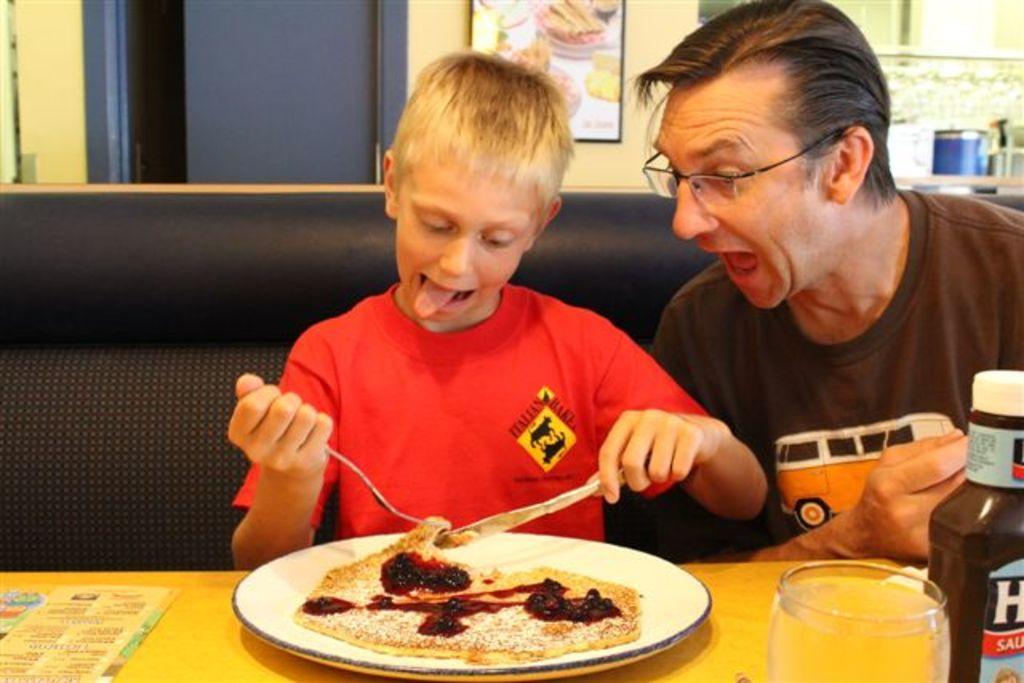Describe this image in one or two sentences. In this image we can see two people. One boy holding a spoon and knife in his hands. At the bottom of the image we can see a card with some text, plate containing food, a glass and a bottle placed on the table. On the right side of the image we can see some containers placed on the surface. At the top of the image we can see the photo frame on the wall and a door. 